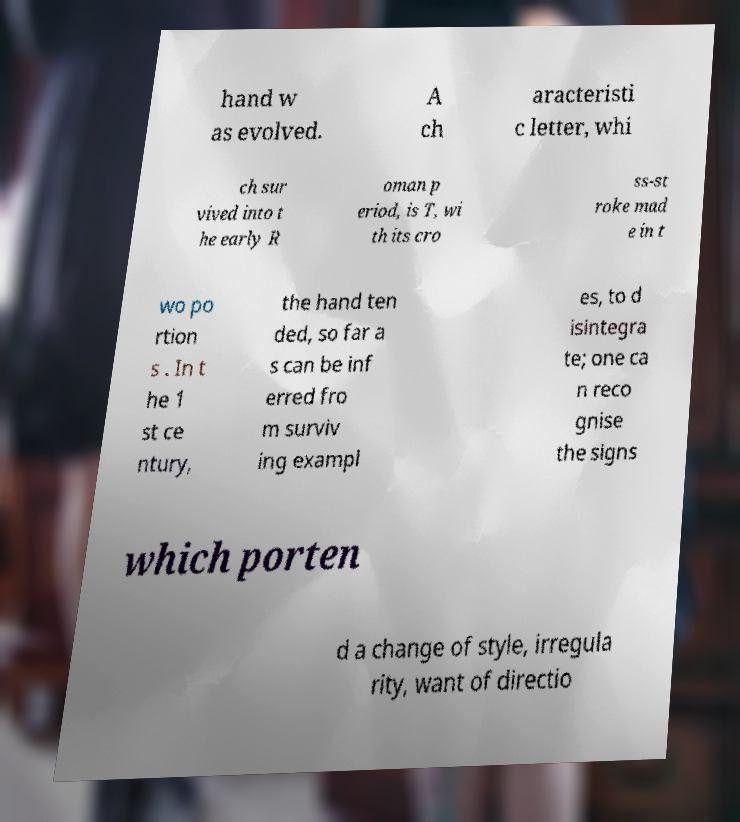There's text embedded in this image that I need extracted. Can you transcribe it verbatim? hand w as evolved. A ch aracteristi c letter, whi ch sur vived into t he early R oman p eriod, is T, wi th its cro ss-st roke mad e in t wo po rtion s . In t he 1 st ce ntury, the hand ten ded, so far a s can be inf erred fro m surviv ing exampl es, to d isintegra te; one ca n reco gnise the signs which porten d a change of style, irregula rity, want of directio 